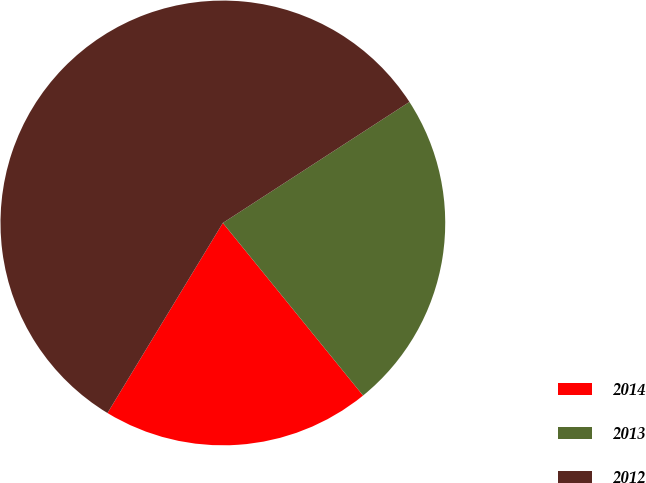<chart> <loc_0><loc_0><loc_500><loc_500><pie_chart><fcel>2014<fcel>2013<fcel>2012<nl><fcel>19.54%<fcel>23.3%<fcel>57.16%<nl></chart> 